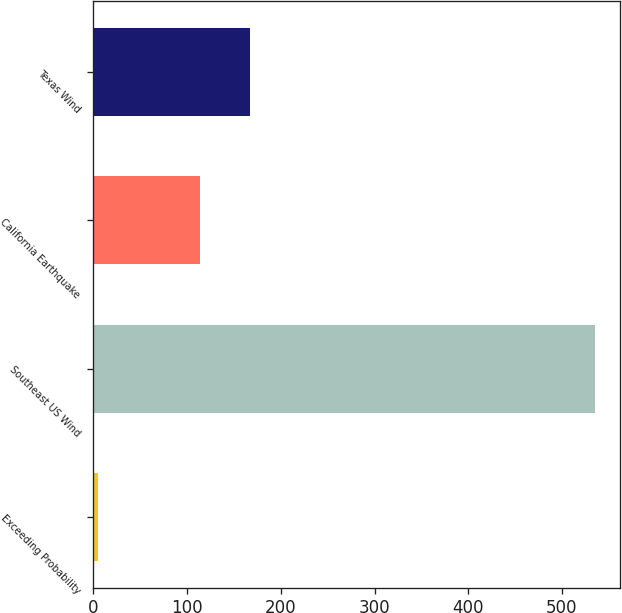Convert chart to OTSL. <chart><loc_0><loc_0><loc_500><loc_500><bar_chart><fcel>Exceeding Probability<fcel>Southeast US Wind<fcel>California Earthquake<fcel>Texas Wind<nl><fcel>5<fcel>535<fcel>114<fcel>167<nl></chart> 